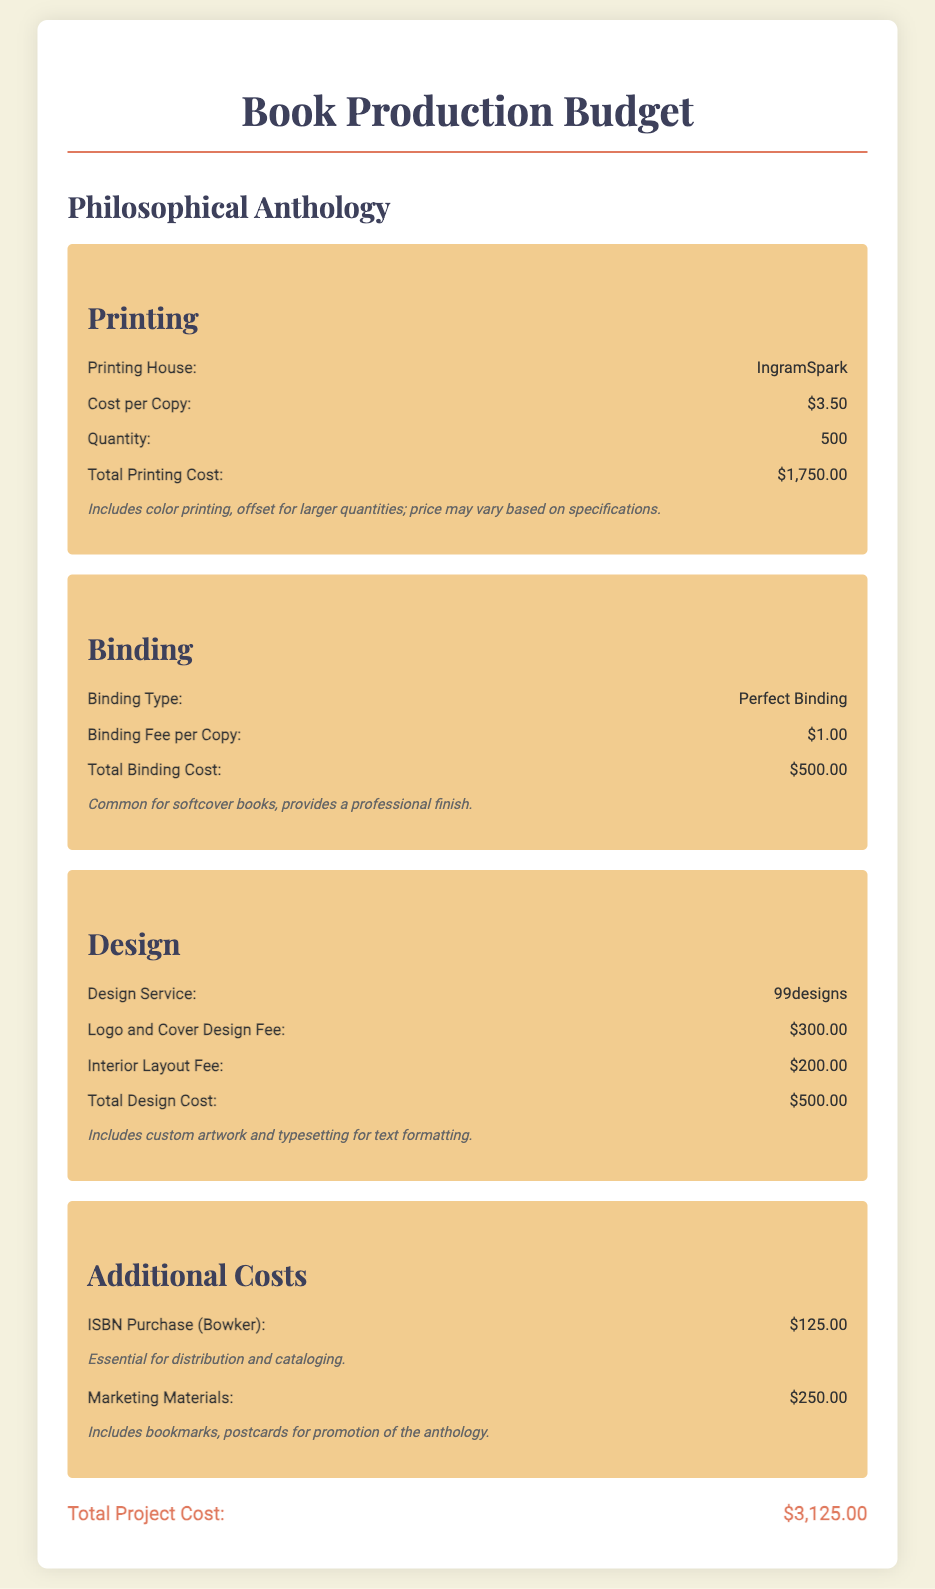What is the printing cost per copy? The printing cost per copy is stated in the budget under printing costs.
Answer: $3.50 What is the total printing cost? The total printing cost is the calculated cost based on the quantity and cost per copy, which is given in the budget.
Answer: $1,750.00 Who is providing the design service? The design service provider is mentioned in the design section of the document.
Answer: 99designs How much is the binding fee per copy? The document specifies the binding fee per copy in the binding section.
Answer: $1.00 What is the total design cost? The total design cost is the sum of the logo and cover design fee and the interior layout fee listed in the budget.
Answer: $500.00 What additional cost is associated with ISBN purchase? The document lists the cost of ISBN purchase, which is essential for distribution and cataloging.
Answer: $125.00 What is the total project cost? The total project cost is provided at the end of the budget summary.
Answer: $3,125.00 What type of binding is used for the anthology? The type of binding is clearly stated in the binding section of the document.
Answer: Perfect Binding What marketing materials are included in the budget? The budget lists marketing materials as part of the additional costs for promotion.
Answer: Bookmarks, postcards 